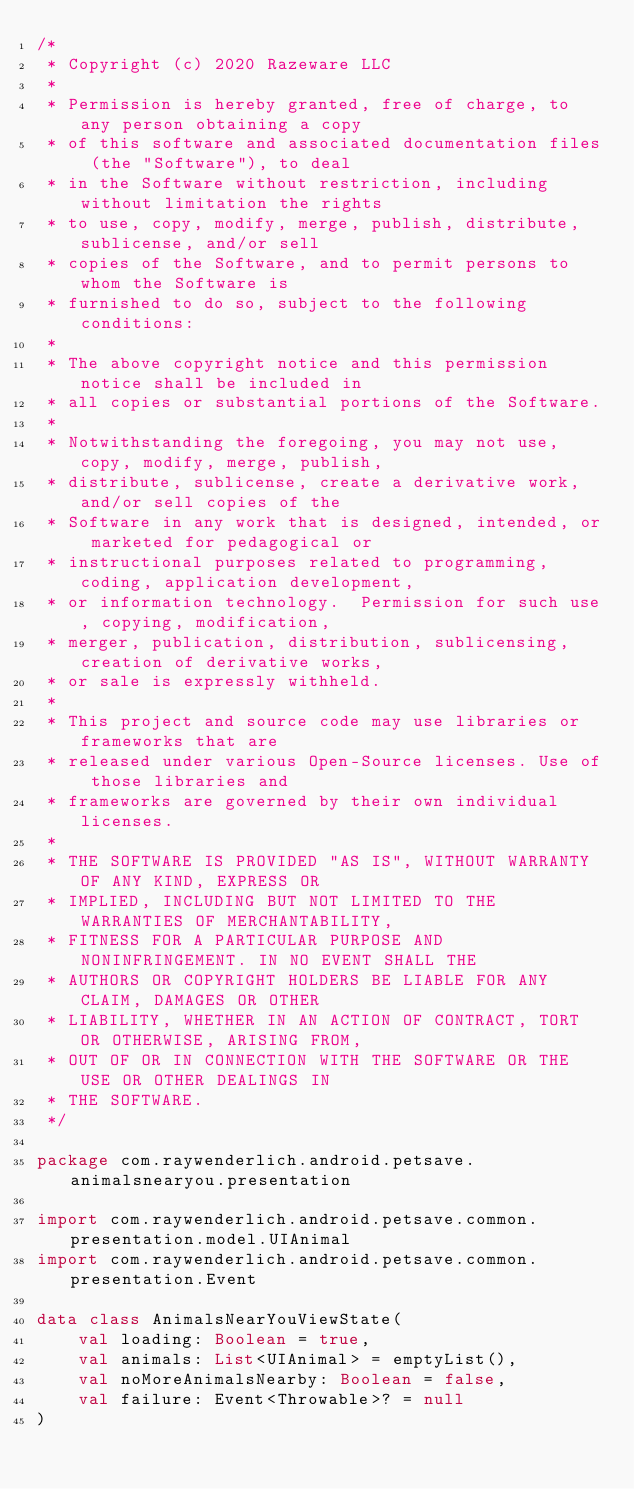Convert code to text. <code><loc_0><loc_0><loc_500><loc_500><_Kotlin_>/*
 * Copyright (c) 2020 Razeware LLC
 *
 * Permission is hereby granted, free of charge, to any person obtaining a copy
 * of this software and associated documentation files (the "Software"), to deal
 * in the Software without restriction, including without limitation the rights
 * to use, copy, modify, merge, publish, distribute, sublicense, and/or sell
 * copies of the Software, and to permit persons to whom the Software is
 * furnished to do so, subject to the following conditions:
 *
 * The above copyright notice and this permission notice shall be included in
 * all copies or substantial portions of the Software.
 *
 * Notwithstanding the foregoing, you may not use, copy, modify, merge, publish,
 * distribute, sublicense, create a derivative work, and/or sell copies of the
 * Software in any work that is designed, intended, or marketed for pedagogical or
 * instructional purposes related to programming, coding, application development,
 * or information technology.  Permission for such use, copying, modification,
 * merger, publication, distribution, sublicensing, creation of derivative works,
 * or sale is expressly withheld.
 *
 * This project and source code may use libraries or frameworks that are
 * released under various Open-Source licenses. Use of those libraries and
 * frameworks are governed by their own individual licenses.
 *
 * THE SOFTWARE IS PROVIDED "AS IS", WITHOUT WARRANTY OF ANY KIND, EXPRESS OR
 * IMPLIED, INCLUDING BUT NOT LIMITED TO THE WARRANTIES OF MERCHANTABILITY,
 * FITNESS FOR A PARTICULAR PURPOSE AND NONINFRINGEMENT. IN NO EVENT SHALL THE
 * AUTHORS OR COPYRIGHT HOLDERS BE LIABLE FOR ANY CLAIM, DAMAGES OR OTHER
 * LIABILITY, WHETHER IN AN ACTION OF CONTRACT, TORT OR OTHERWISE, ARISING FROM,
 * OUT OF OR IN CONNECTION WITH THE SOFTWARE OR THE USE OR OTHER DEALINGS IN
 * THE SOFTWARE.
 */

package com.raywenderlich.android.petsave.animalsnearyou.presentation

import com.raywenderlich.android.petsave.common.presentation.model.UIAnimal
import com.raywenderlich.android.petsave.common.presentation.Event

data class AnimalsNearYouViewState(
    val loading: Boolean = true,
    val animals: List<UIAnimal> = emptyList(),
    val noMoreAnimalsNearby: Boolean = false,
    val failure: Event<Throwable>? = null
)</code> 